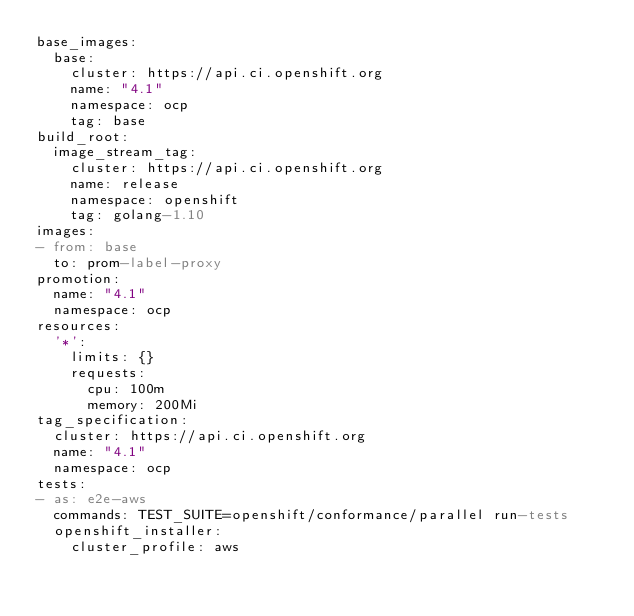<code> <loc_0><loc_0><loc_500><loc_500><_YAML_>base_images:
  base:
    cluster: https://api.ci.openshift.org
    name: "4.1"
    namespace: ocp
    tag: base
build_root:
  image_stream_tag:
    cluster: https://api.ci.openshift.org
    name: release
    namespace: openshift
    tag: golang-1.10
images:
- from: base
  to: prom-label-proxy
promotion:
  name: "4.1"
  namespace: ocp
resources:
  '*':
    limits: {}
    requests:
      cpu: 100m
      memory: 200Mi
tag_specification:
  cluster: https://api.ci.openshift.org
  name: "4.1"
  namespace: ocp
tests:
- as: e2e-aws
  commands: TEST_SUITE=openshift/conformance/parallel run-tests
  openshift_installer:
    cluster_profile: aws
</code> 